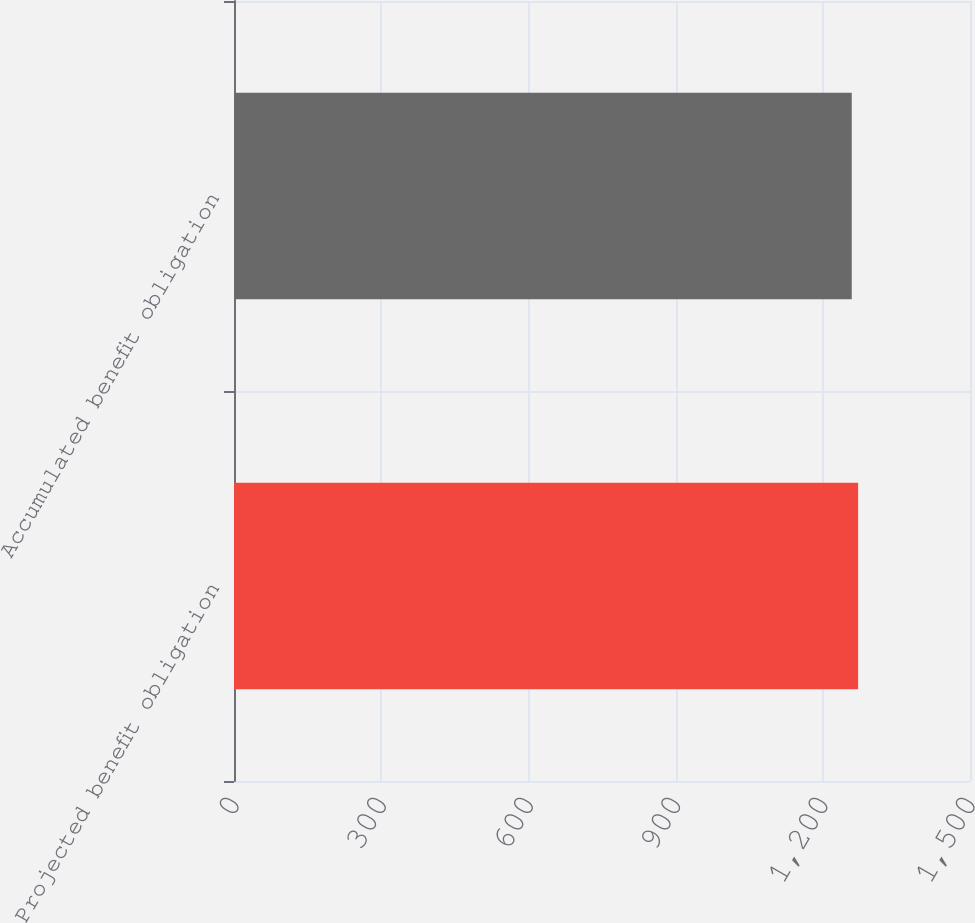<chart> <loc_0><loc_0><loc_500><loc_500><bar_chart><fcel>Projected benefit obligation<fcel>Accumulated benefit obligation<nl><fcel>1272<fcel>1259<nl></chart> 